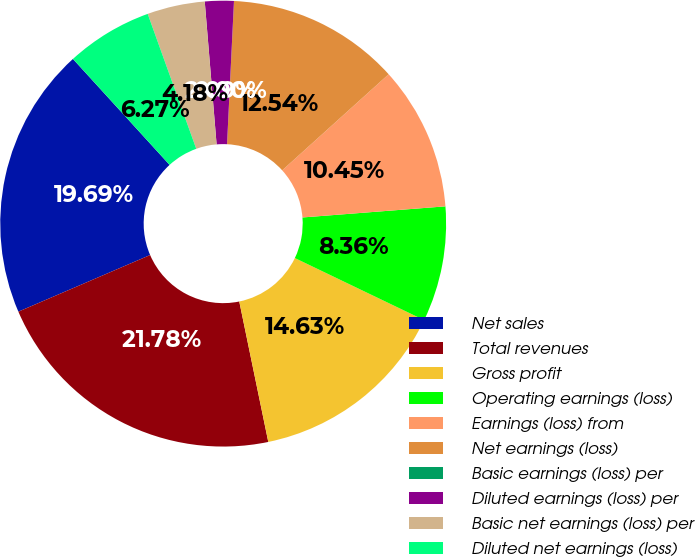Convert chart to OTSL. <chart><loc_0><loc_0><loc_500><loc_500><pie_chart><fcel>Net sales<fcel>Total revenues<fcel>Gross profit<fcel>Operating earnings (loss)<fcel>Earnings (loss) from<fcel>Net earnings (loss)<fcel>Basic earnings (loss) per<fcel>Diluted earnings (loss) per<fcel>Basic net earnings (loss) per<fcel>Diluted net earnings (loss)<nl><fcel>19.69%<fcel>21.78%<fcel>14.63%<fcel>8.36%<fcel>10.45%<fcel>12.54%<fcel>0.0%<fcel>2.09%<fcel>4.18%<fcel>6.27%<nl></chart> 